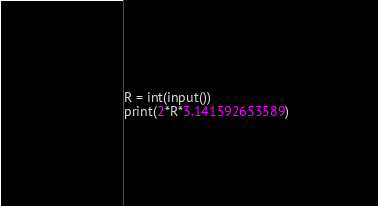Convert code to text. <code><loc_0><loc_0><loc_500><loc_500><_Python_>R = int(input())
print(2*R*3.141592653589)</code> 